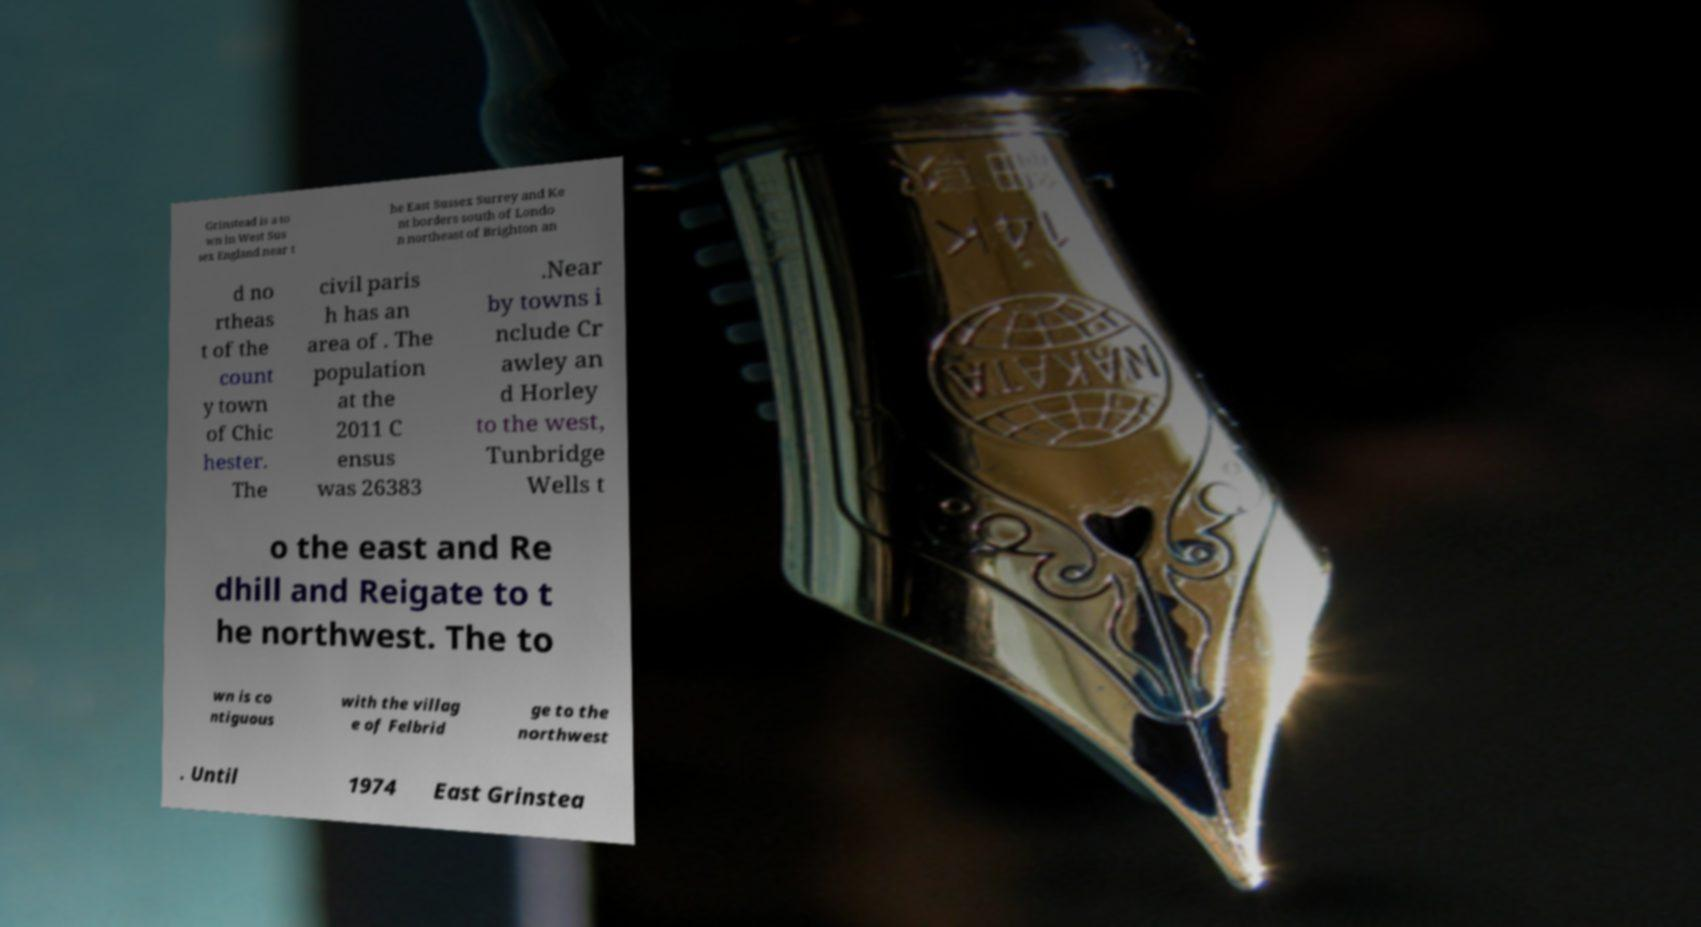Can you read and provide the text displayed in the image?This photo seems to have some interesting text. Can you extract and type it out for me? Grinstead is a to wn in West Sus sex England near t he East Sussex Surrey and Ke nt borders south of Londo n northeast of Brighton an d no rtheas t of the count y town of Chic hester. The civil paris h has an area of . The population at the 2011 C ensus was 26383 .Near by towns i nclude Cr awley an d Horley to the west, Tunbridge Wells t o the east and Re dhill and Reigate to t he northwest. The to wn is co ntiguous with the villag e of Felbrid ge to the northwest . Until 1974 East Grinstea 